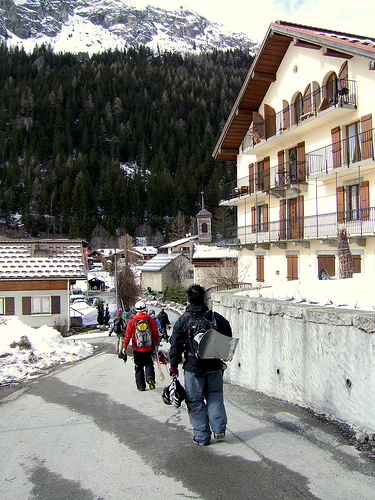<image>
Can you confirm if the man is behind the house? Yes. From this viewpoint, the man is positioned behind the house, with the house partially or fully occluding the man. 